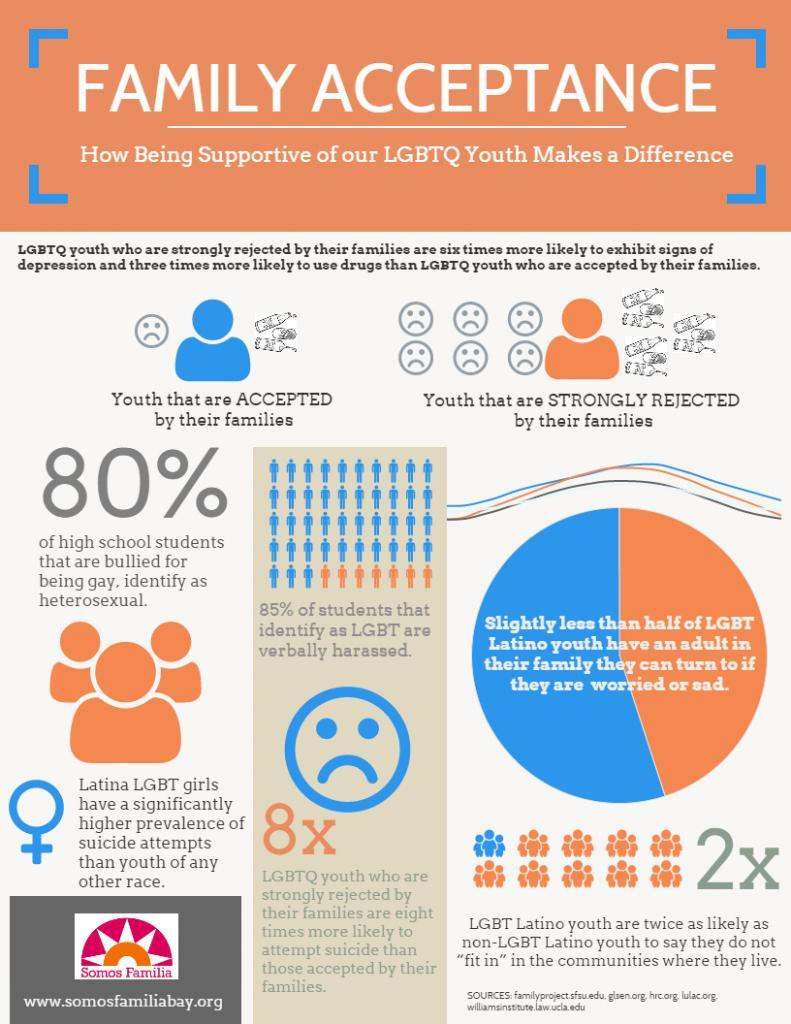which community are twice likely to say that they do not fit in
Answer the question with a short phrase. LGBT latino youth what % of students bullied for being day are heterosexual 80% what percentage of students identified as LGBT are not verbally harassed 15 